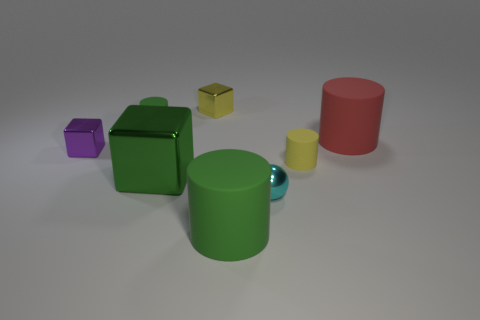Add 1 large green cylinders. How many objects exist? 9 Subtract all red matte cylinders. How many cylinders are left? 3 Subtract all yellow blocks. How many blocks are left? 2 Subtract 2 cylinders. How many cylinders are left? 2 Subtract all brown balls. How many red cylinders are left? 1 Subtract all large gray matte blocks. Subtract all tiny green cylinders. How many objects are left? 7 Add 3 tiny blocks. How many tiny blocks are left? 5 Add 4 large gray shiny cylinders. How many large gray shiny cylinders exist? 4 Subtract 0 red blocks. How many objects are left? 8 Subtract all spheres. How many objects are left? 7 